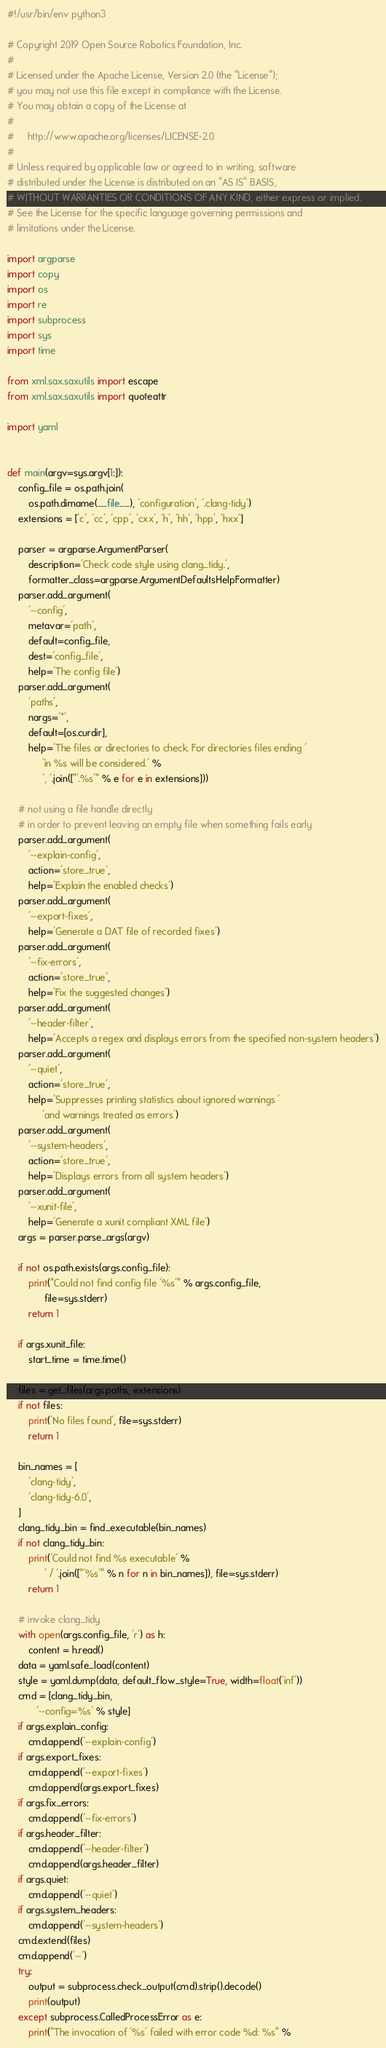<code> <loc_0><loc_0><loc_500><loc_500><_Python_>#!/usr/bin/env python3

# Copyright 2019 Open Source Robotics Foundation, Inc.
#
# Licensed under the Apache License, Version 2.0 (the "License");
# you may not use this file except in compliance with the License.
# You may obtain a copy of the License at
#
#     http://www.apache.org/licenses/LICENSE-2.0
#
# Unless required by applicable law or agreed to in writing, software
# distributed under the License is distributed on an "AS IS" BASIS,
# WITHOUT WARRANTIES OR CONDITIONS OF ANY KIND, either express or implied.
# See the License for the specific language governing permissions and
# limitations under the License.

import argparse
import copy
import os
import re
import subprocess
import sys
import time

from xml.sax.saxutils import escape
from xml.sax.saxutils import quoteattr

import yaml


def main(argv=sys.argv[1:]):
    config_file = os.path.join(
        os.path.dirname(__file__), 'configuration', '.clang-tidy')
    extensions = ['c', 'cc', 'cpp', 'cxx', 'h', 'hh', 'hpp', 'hxx']

    parser = argparse.ArgumentParser(
        description='Check code style using clang_tidy.',
        formatter_class=argparse.ArgumentDefaultsHelpFormatter)
    parser.add_argument(
        '--config',
        metavar='path',
        default=config_file,
        dest='config_file',
        help='The config file')
    parser.add_argument(
        'paths',
        nargs='*',
        default=[os.curdir],
        help='The files or directories to check. For directories files ending '
             'in %s will be considered.' %
             ', '.join(["'.%s'" % e for e in extensions]))

    # not using a file handle directly
    # in order to prevent leaving an empty file when something fails early
    parser.add_argument(
        '--explain-config',
        action='store_true',
        help='Explain the enabled checks')
    parser.add_argument(
        '--export-fixes',
        help='Generate a DAT file of recorded fixes')
    parser.add_argument(
        '--fix-errors',
        action='store_true',
        help='Fix the suggested changes')
    parser.add_argument(
        '--header-filter',
        help='Accepts a regex and displays errors from the specified non-system headers')
    parser.add_argument(
        '--quiet',
        action='store_true',
        help='Suppresses printing statistics about ignored warnings '
             'and warnings treated as errors')
    parser.add_argument(
        '--system-headers',
        action='store_true',
        help='Displays errors from all system headers')
    parser.add_argument(
        '--xunit-file',
        help='Generate a xunit compliant XML file')
    args = parser.parse_args(argv)

    if not os.path.exists(args.config_file):
        print("Could not find config file '%s'" % args.config_file,
              file=sys.stderr)
        return 1

    if args.xunit_file:
        start_time = time.time()

    files = get_files(args.paths, extensions)
    if not files:
        print('No files found', file=sys.stderr)
        return 1

    bin_names = [
        'clang-tidy',
        'clang-tidy-6.0',
    ]
    clang_tidy_bin = find_executable(bin_names)
    if not clang_tidy_bin:
        print('Could not find %s executable' %
              ' / '.join(["'%s'" % n for n in bin_names]), file=sys.stderr)
        return 1

    # invoke clang_tidy
    with open(args.config_file, 'r') as h:
        content = h.read()
    data = yaml.safe_load(content)
    style = yaml.dump(data, default_flow_style=True, width=float('inf'))
    cmd = [clang_tidy_bin,
           '--config=%s' % style]
    if args.explain_config:
        cmd.append('--explain-config')
    if args.export_fixes:
        cmd.append('--export-fixes')
        cmd.append(args.export_fixes)
    if args.fix_errors:
        cmd.append('--fix-errors')
    if args.header_filter:
        cmd.append('--header-filter')
        cmd.append(args.header_filter)
    if args.quiet:
        cmd.append('--quiet')
    if args.system_headers:
        cmd.append('--system-headers')
    cmd.extend(files)
    cmd.append('--')
    try:
        output = subprocess.check_output(cmd).strip().decode()
        print(output)
    except subprocess.CalledProcessError as e:
        print("The invocation of '%s' failed with error code %d: %s" %</code> 